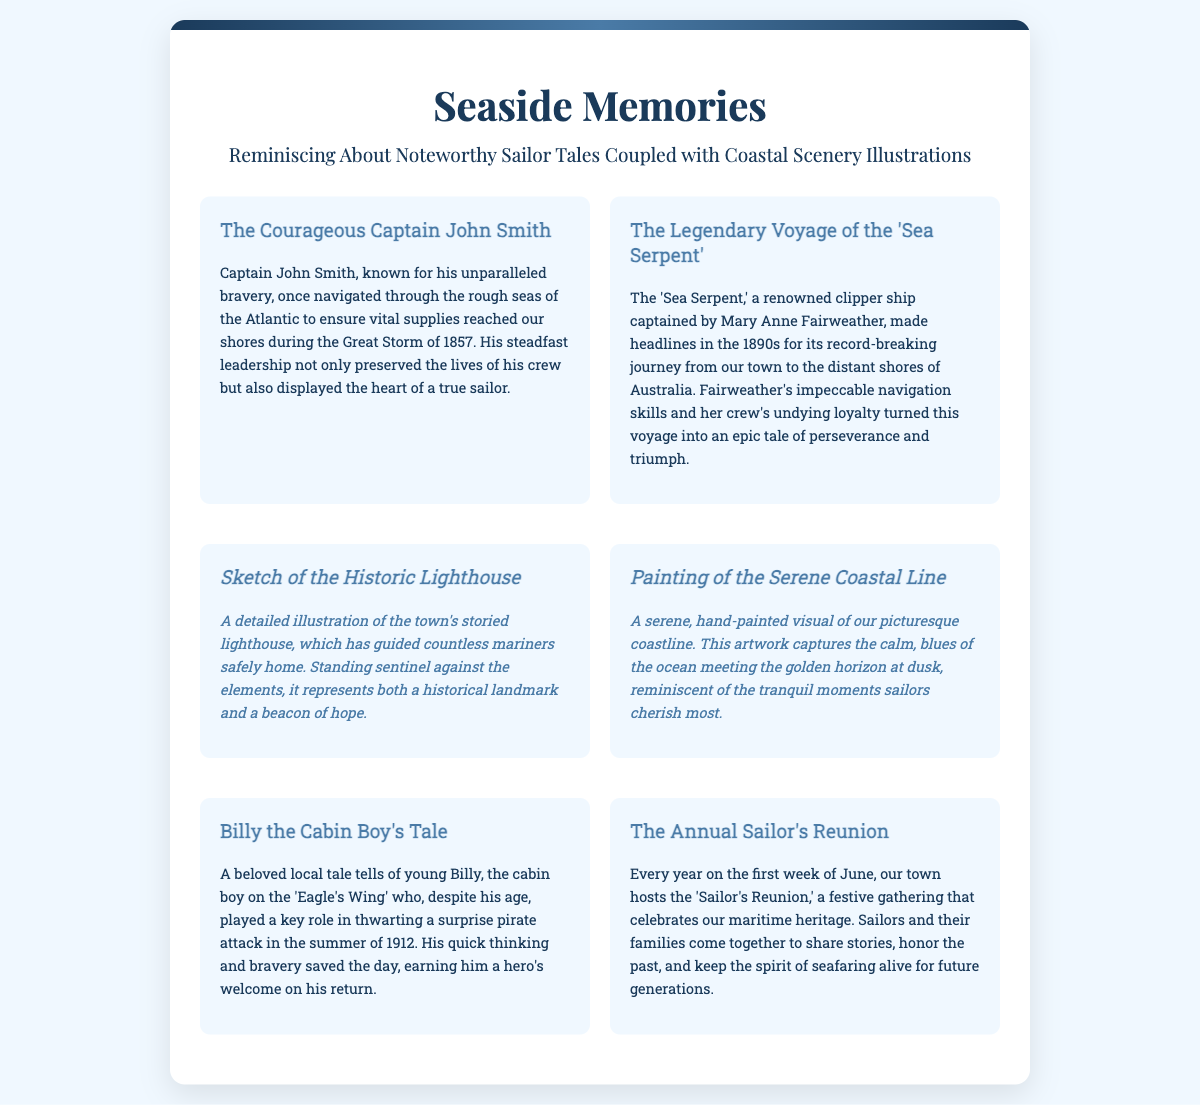What was Captain John Smith known for? Captain John Smith was known for his unparalleled bravery.
Answer: unparalleled bravery What year did the Great Storm occur? The Great Storm occurred in 1857.
Answer: 1857 Who captained the 'Sea Serpent'? The 'Sea Serpent' was captained by Mary Anne Fairweather.
Answer: Mary Anne Fairweather What age was Billy the Cabin Boy during his notable tale? Billy was young, but his exact age is not specified.
Answer: young When is the Annual Sailor's Reunion held? The Annual Sailor's Reunion is held on the first week of June.
Answer: first week of June What type of illustration is featured alongside the lighthouse? A detailed illustration is featured.
Answer: detailed illustration What does the painting of the coastline represent? The painting represents tranquil moments sailors cherish.
Answer: tranquil moments How did Billy contribute to thwarting the pirate attack? Billy's quick thinking and bravery saved the day.
Answer: quick thinking and bravery What is the main theme of the greeting card? The main theme is reminiscing about noteworthy sailor tales.
Answer: noteworthy sailor tales 